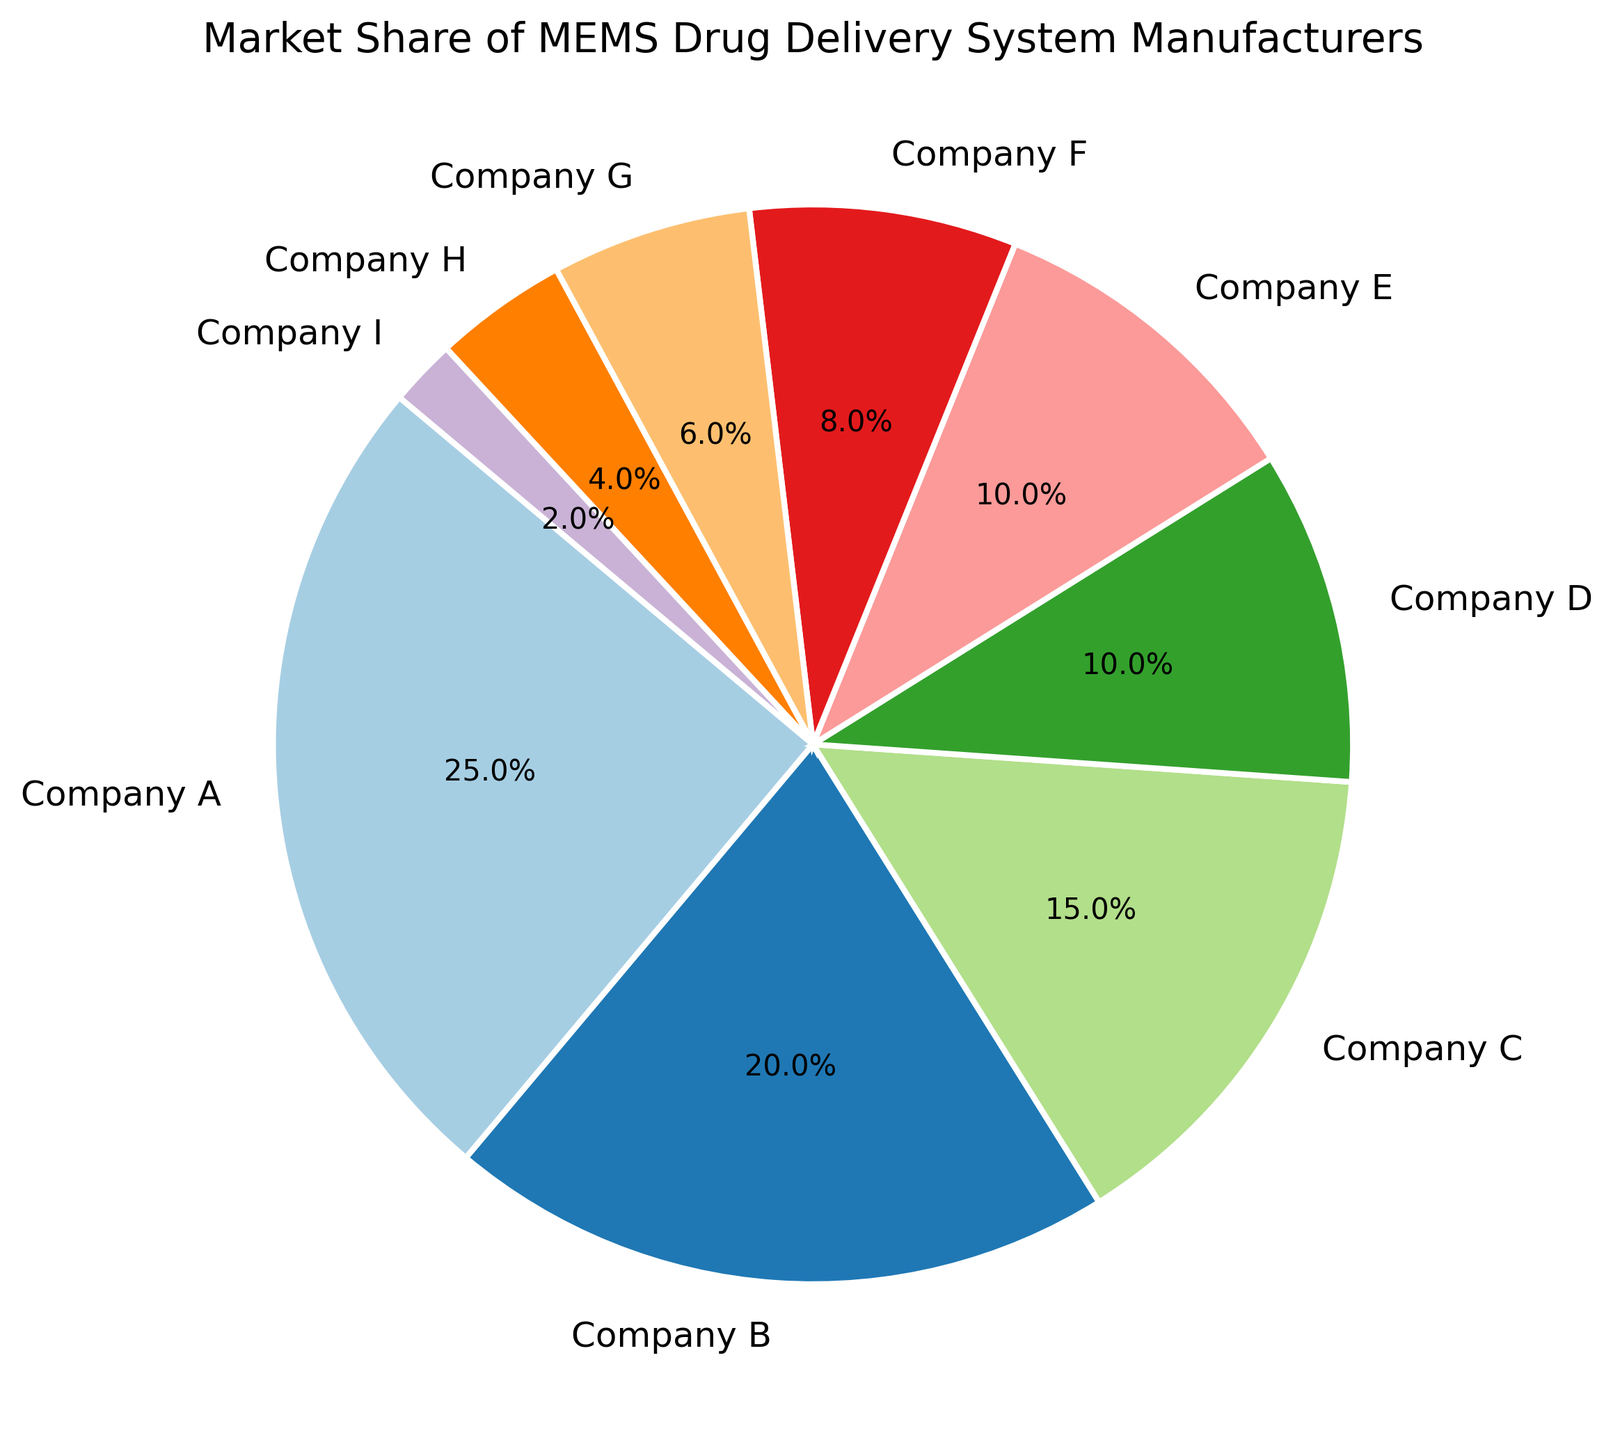What is the market share of Company A? The figure shows the market share of various companies. Company A has a market share of 25%.
Answer: 25% Which company has the smallest market share? Reviewing the pie chart, Company I has the smallest market share, which is 2%.
Answer: Company I Which company has a larger market share, Company B or Company C? Comparing the two companies on the pie chart, Company B has a market share of 20% and Company C has 15%. Therefore, Company B has a larger market share.
Answer: Company B What is the combined market share of Company D and Company E? The market shares for Company D and Company E are 10% each. Adding these together, 10% + 10% = 20%.
Answer: 20% How much larger is the market share of Company A compared to Company F? Company A's market share is 25%, and Company F's is 8%. Subtracting these, 25% - 8% = 17%.
Answer: 17% Which company has a smaller market share, Company G or Company H? Company G has a market share of 6%, and Company H has 4%. Thus, Company H has a smaller market share.
Answer: Company H What is the combined market share of the companies with less than 10% market share? Companies F (8%), G (6%), H (4%), and I (2%) each have less than 10% market share. Their combined market share is 8% + 6% + 4% + 2% = 20%.
Answer: 20% What is the total market share of all companies listed? Adding the market shares of all companies: 25% + 20% + 15% + 10% + 10% + 8% + 6% + 4% + 2% = 100%.
Answer: 100% Among companies with market shares greater than 10%, which company has the smallest share? Companies with market shares greater than 10% are Company A (25%), Company B (20%), and Company C (15%). Among them, Company C has the smallest share.
Answer: Company C What is the market share difference between the company with the highest share and the company with the lowest share? Company A has the highest share at 25%, and Company I has the lowest at 2%. The difference is 25% - 2% = 23%.
Answer: 23% 